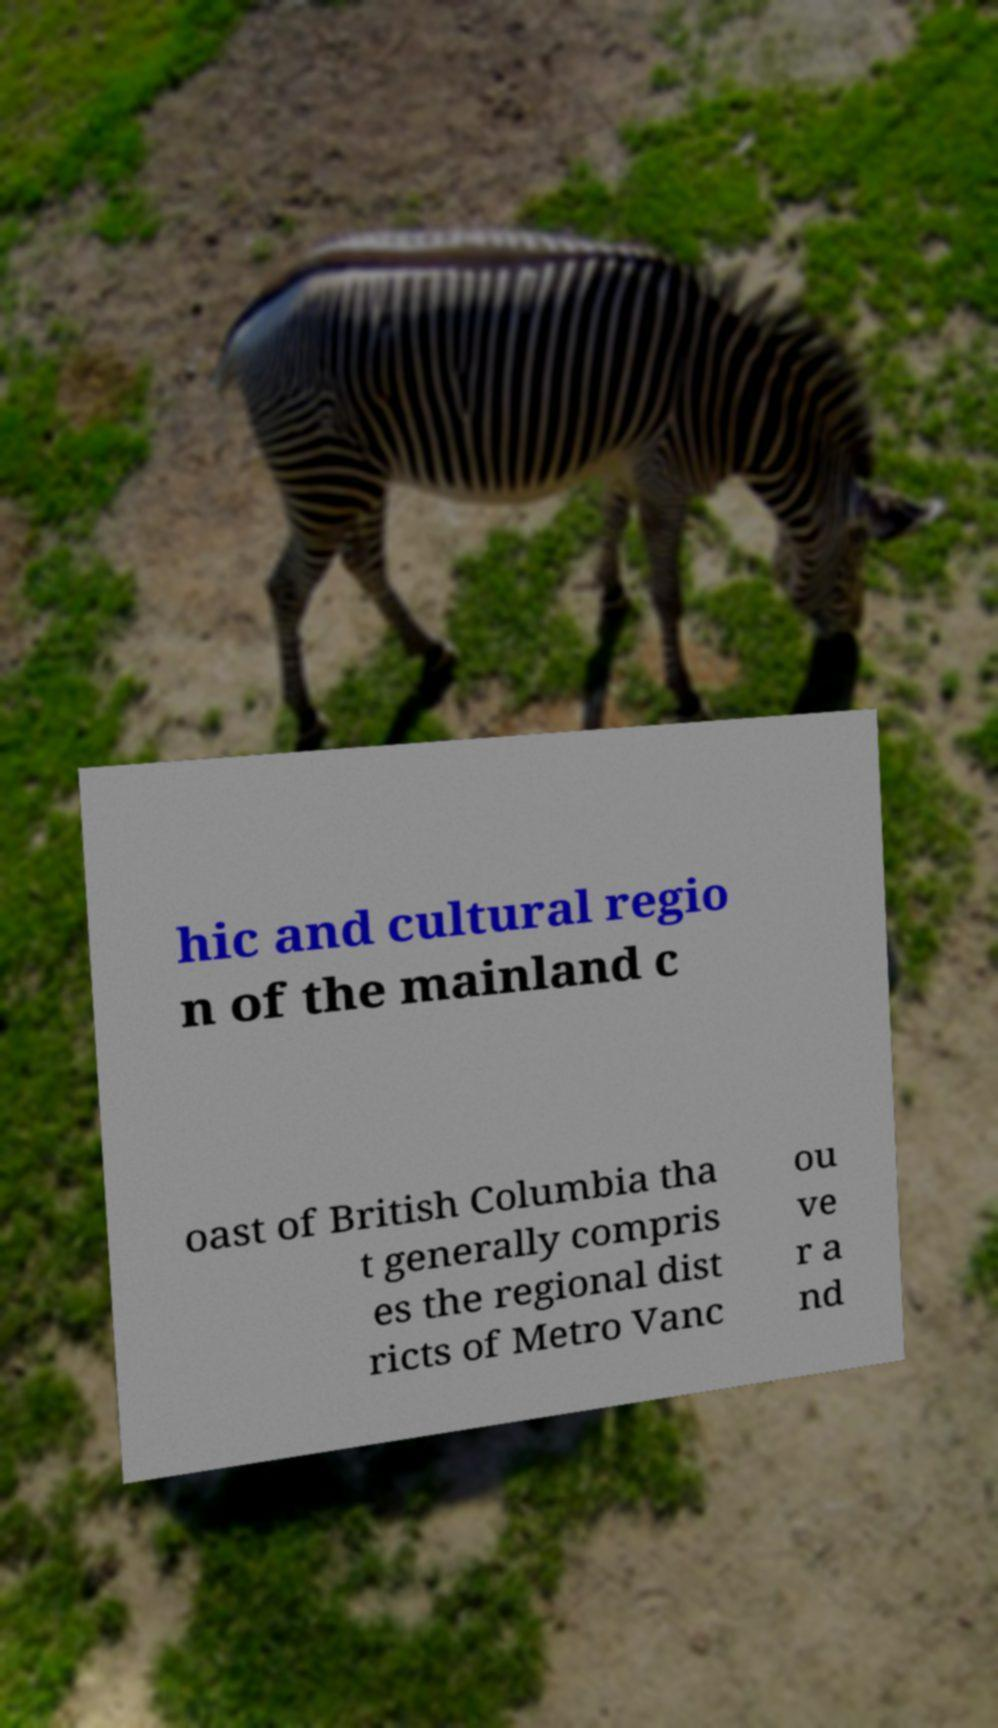Could you assist in decoding the text presented in this image and type it out clearly? hic and cultural regio n of the mainland c oast of British Columbia tha t generally compris es the regional dist ricts of Metro Vanc ou ve r a nd 